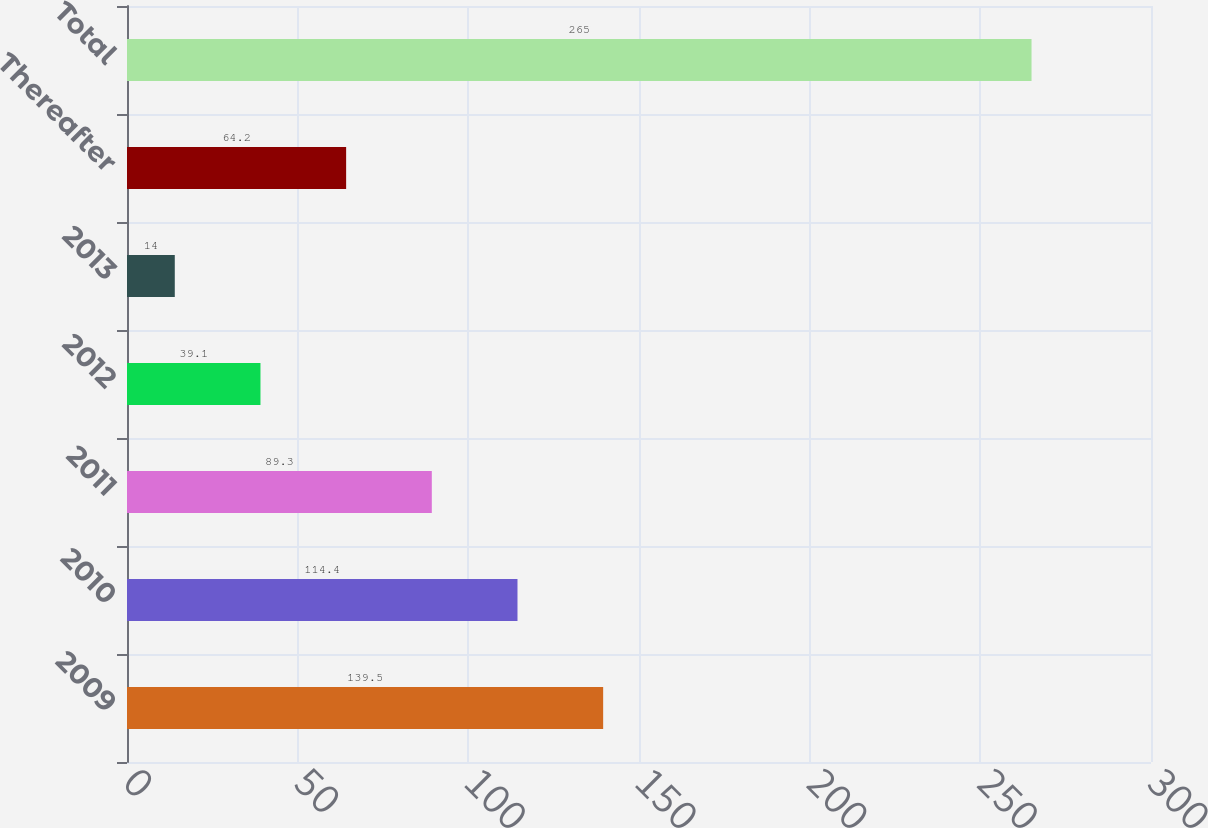Convert chart to OTSL. <chart><loc_0><loc_0><loc_500><loc_500><bar_chart><fcel>2009<fcel>2010<fcel>2011<fcel>2012<fcel>2013<fcel>Thereafter<fcel>Total<nl><fcel>139.5<fcel>114.4<fcel>89.3<fcel>39.1<fcel>14<fcel>64.2<fcel>265<nl></chart> 